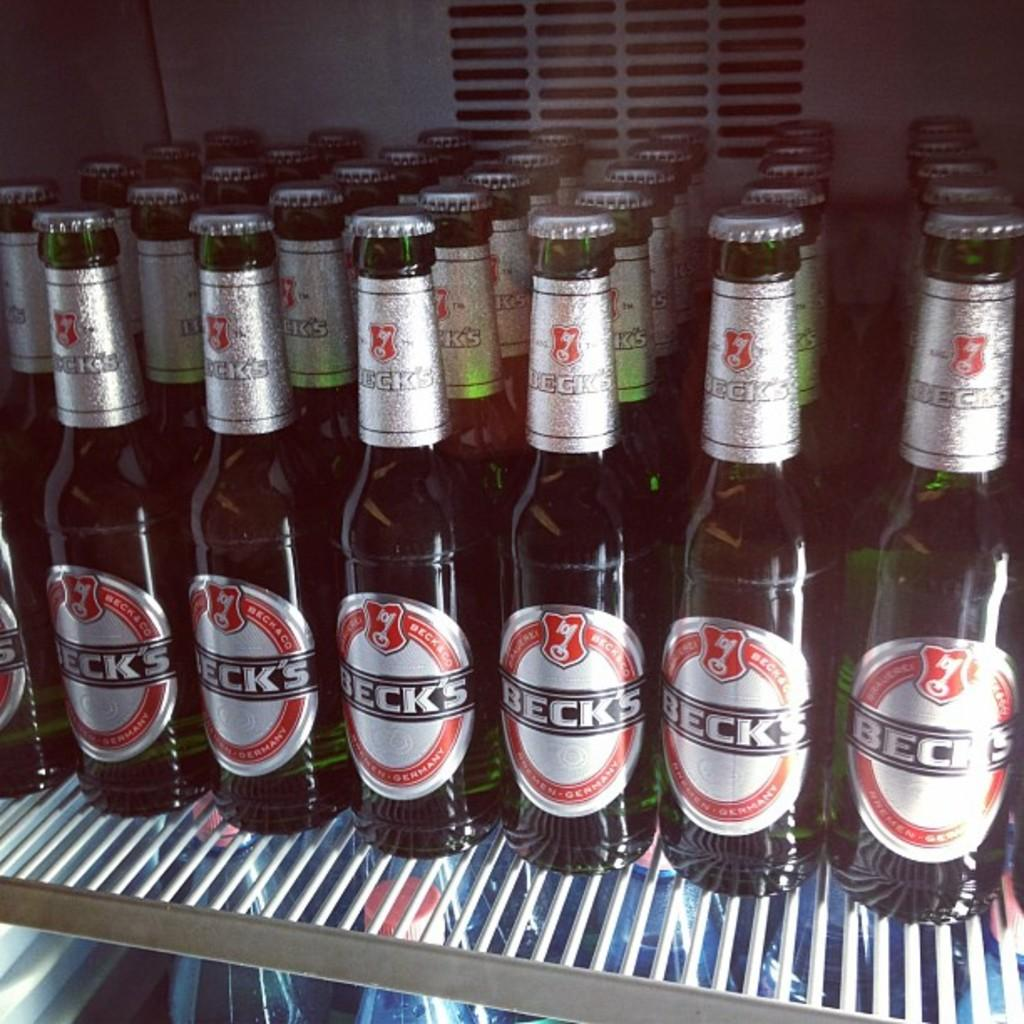<image>
Write a terse but informative summary of the picture. Bottles of Beck's beer is lined up on a refrigerator shelf. 